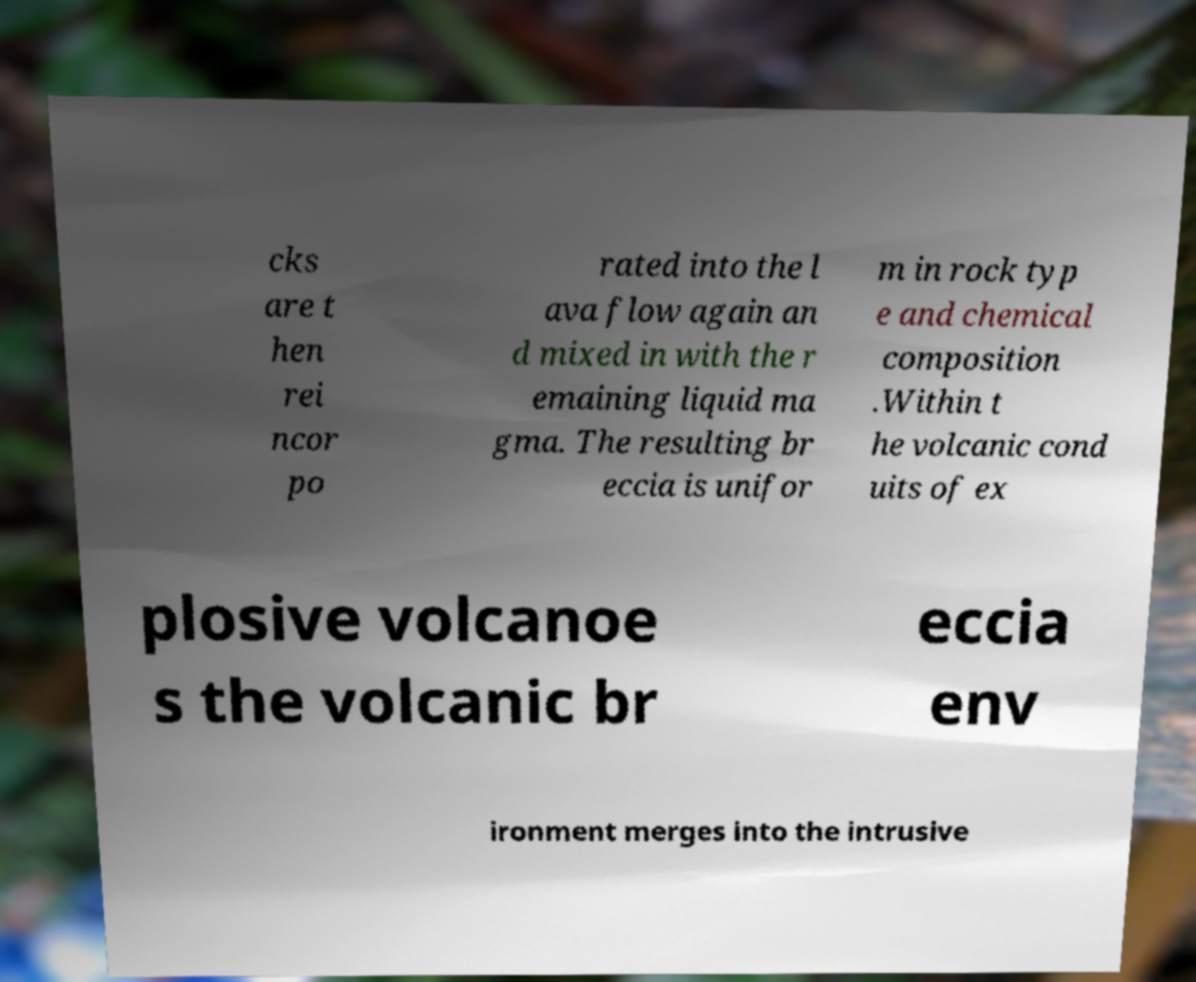What messages or text are displayed in this image? I need them in a readable, typed format. cks are t hen rei ncor po rated into the l ava flow again an d mixed in with the r emaining liquid ma gma. The resulting br eccia is unifor m in rock typ e and chemical composition .Within t he volcanic cond uits of ex plosive volcanoe s the volcanic br eccia env ironment merges into the intrusive 